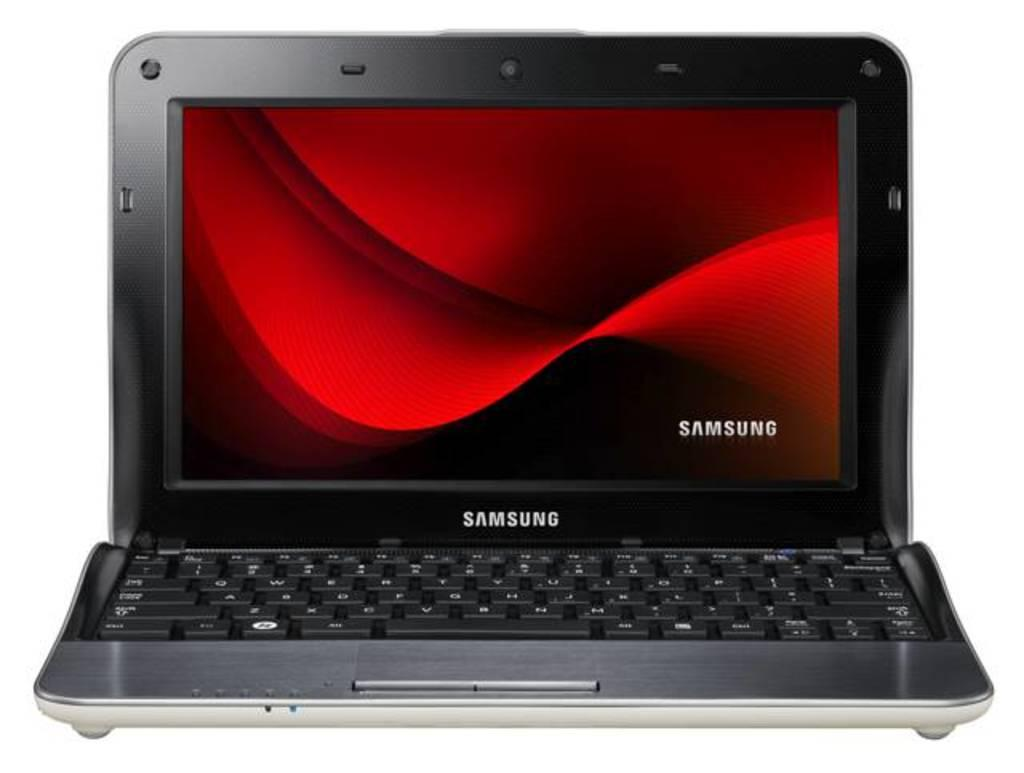<image>
Provide a brief description of the given image. The black and red laptop has the name Samsung on it 